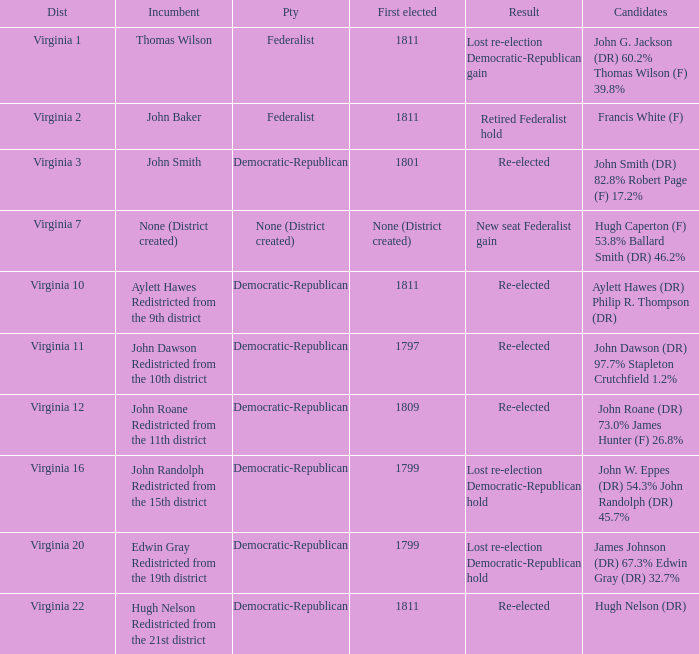Name the party for  john randolph redistricted from the 15th district Democratic-Republican. 